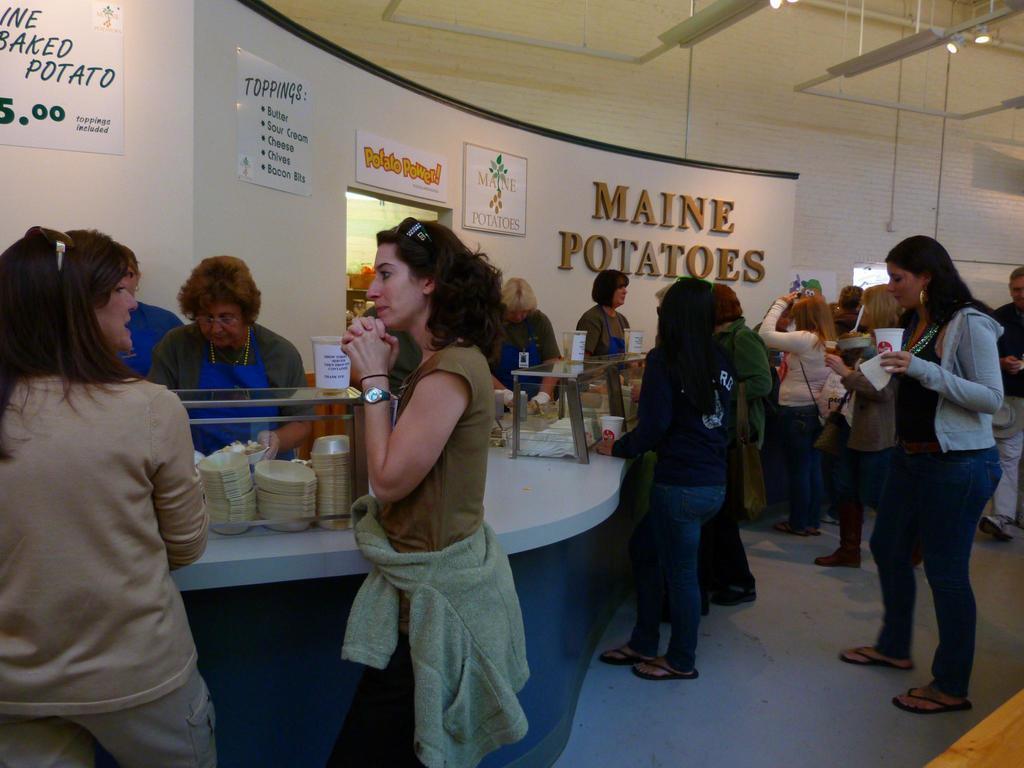How would you summarize this image in a sentence or two? In this image we can see some group of persons standing and having some food items and in the background of the image there are some lady persons standing behind the counter, there are some boards, paintings attached to the wall. 